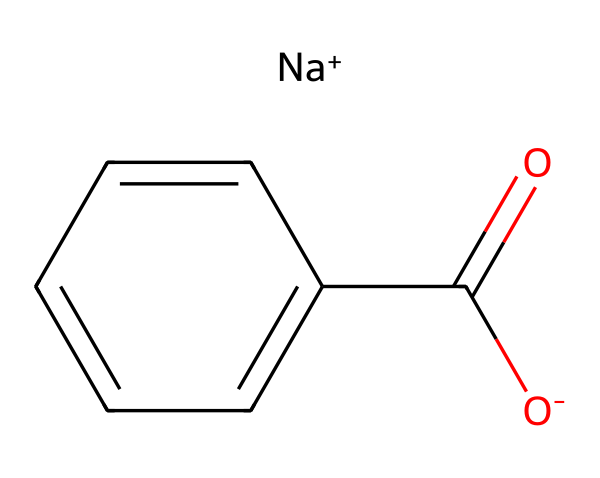What is the total number of carbon atoms in sodium benzoate? In the SMILES representation, the 'C' denotes the carbon atoms. There is a carboxylate group (C(=O)O-) which includes one carbon, and the phenyl ring (c1ccccc1) which consists of six carbon atoms. So, 1 (from the carboxylate) + 6 (from the ring) = 7 carbon atoms total.
Answer: 7 How many oxygen atoms are present in sodium benzoate? In the given SMILES, the 'O' appears twice: once in the carboxylate (O-) and once in the carbonyl (C=O), totaling two oxygen atoms.
Answer: 2 What type of chemical compound is sodium benzoate? Sodium benzoate is classified as a preservative, and specifically, it is a sodium salt of benzoic acid used primarily in food preservation.
Answer: preservative What functional group characterizes sodium benzoate? The functional group present in sodium benzoate is the carboxylate group, represented as 'C(=O)O-', which indicates it is a salt derived from benzoic acid.
Answer: carboxylate How many aromatic rings are present in sodium benzoate? The aromatic part of the chemical is indicated by the 'c' in the SMILES notation, which signifies the benzene ring structure. There is one benzene ring in sodium benzoate.
Answer: 1 Is sodium benzoate soluble in water? Sodium benzoate is an ionic compound due to the presence of sodium ion ([Na+]) and its carboxylate group which makes it soluble in water.
Answer: yes What is the main reason sodium benzoate is used as a food preservative? Sodium benzoate prevents the growth of bacteria, yeast, and fungi in acidic foods, effectively extending their shelf life.
Answer: inhibits microbial growth 